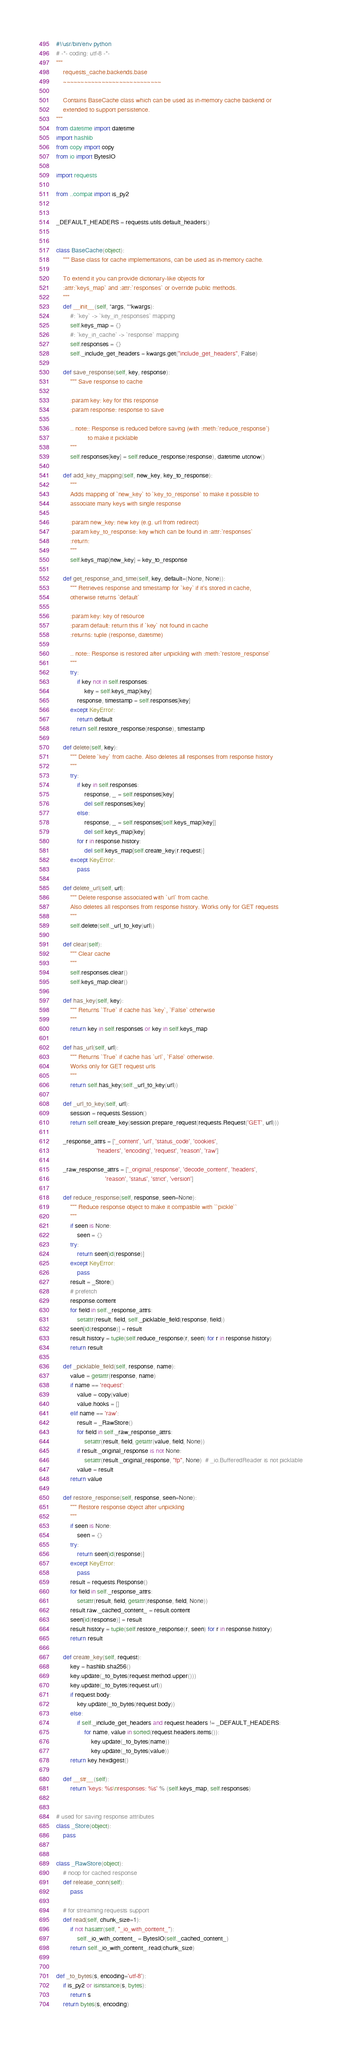<code> <loc_0><loc_0><loc_500><loc_500><_Python_>#!/usr/bin/env python
# -*- coding: utf-8 -*-
"""
    requests_cache.backends.base
    ~~~~~~~~~~~~~~~~~~~~~~~~~~~~

    Contains BaseCache class which can be used as in-memory cache backend or
    extended to support persistence.
"""
from datetime import datetime
import hashlib
from copy import copy
from io import BytesIO

import requests

from ..compat import is_py2


_DEFAULT_HEADERS = requests.utils.default_headers()


class BaseCache(object):
    """ Base class for cache implementations, can be used as in-memory cache.

    To extend it you can provide dictionary-like objects for
    :attr:`keys_map` and :attr:`responses` or override public methods.
    """
    def __init__(self, *args, **kwargs):
        #: `key` -> `key_in_responses` mapping
        self.keys_map = {}
        #: `key_in_cache` -> `response` mapping
        self.responses = {}
        self._include_get_headers = kwargs.get("include_get_headers", False)

    def save_response(self, key, response):
        """ Save response to cache

        :param key: key for this response
        :param response: response to save

        .. note:: Response is reduced before saving (with :meth:`reduce_response`)
                  to make it picklable
        """
        self.responses[key] = self.reduce_response(response), datetime.utcnow()

    def add_key_mapping(self, new_key, key_to_response):
        """
        Adds mapping of `new_key` to `key_to_response` to make it possible to
        associate many keys with single response

        :param new_key: new key (e.g. url from redirect)
        :param key_to_response: key which can be found in :attr:`responses`
        :return:
        """
        self.keys_map[new_key] = key_to_response

    def get_response_and_time(self, key, default=(None, None)):
        """ Retrieves response and timestamp for `key` if it's stored in cache,
        otherwise returns `default`

        :param key: key of resource
        :param default: return this if `key` not found in cache
        :returns: tuple (response, datetime)

        .. note:: Response is restored after unpickling with :meth:`restore_response`
        """
        try:
            if key not in self.responses:
                key = self.keys_map[key]
            response, timestamp = self.responses[key]
        except KeyError:
            return default
        return self.restore_response(response), timestamp

    def delete(self, key):
        """ Delete `key` from cache. Also deletes all responses from response history
        """
        try:
            if key in self.responses:
                response, _ = self.responses[key]
                del self.responses[key]
            else:
                response, _ = self.responses[self.keys_map[key]]
                del self.keys_map[key]
            for r in response.history:
                del self.keys_map[self.create_key(r.request)]
        except KeyError:
            pass

    def delete_url(self, url):
        """ Delete response associated with `url` from cache.
        Also deletes all responses from response history. Works only for GET requests
        """
        self.delete(self._url_to_key(url))

    def clear(self):
        """ Clear cache
        """
        self.responses.clear()
        self.keys_map.clear()

    def has_key(self, key):
        """ Returns `True` if cache has `key`, `False` otherwise
        """
        return key in self.responses or key in self.keys_map

    def has_url(self, url):
        """ Returns `True` if cache has `url`, `False` otherwise.
        Works only for GET request urls
        """
        return self.has_key(self._url_to_key(url))

    def _url_to_key(self, url):
        session = requests.Session()
        return self.create_key(session.prepare_request(requests.Request('GET', url)))

    _response_attrs = ['_content', 'url', 'status_code', 'cookies',
                       'headers', 'encoding', 'request', 'reason', 'raw']

    _raw_response_attrs = ['_original_response', 'decode_content', 'headers',
                            'reason', 'status', 'strict', 'version']

    def reduce_response(self, response, seen=None):
        """ Reduce response object to make it compatible with ``pickle``
        """
        if seen is None:
            seen = {}
        try:
            return seen[id(response)]
        except KeyError:
            pass
        result = _Store()
        # prefetch
        response.content
        for field in self._response_attrs:
            setattr(result, field, self._picklable_field(response, field))
        seen[id(response)] = result
        result.history = tuple(self.reduce_response(r, seen) for r in response.history)
        return result

    def _picklable_field(self, response, name):
        value = getattr(response, name)
        if name == 'request':
            value = copy(value)
            value.hooks = []
        elif name == 'raw':
            result = _RawStore()
            for field in self._raw_response_attrs:
                setattr(result, field, getattr(value, field, None))
            if result._original_response is not None:
                setattr(result._original_response, "fp", None)  # _io.BufferedReader is not picklable
            value = result
        return value

    def restore_response(self, response, seen=None):
        """ Restore response object after unpickling
        """
        if seen is None:
            seen = {}
        try:
            return seen[id(response)]
        except KeyError:
            pass
        result = requests.Response()
        for field in self._response_attrs:
            setattr(result, field, getattr(response, field, None))
        result.raw._cached_content_ = result.content
        seen[id(response)] = result
        result.history = tuple(self.restore_response(r, seen) for r in response.history)
        return result

    def create_key(self, request):
        key = hashlib.sha256()
        key.update(_to_bytes(request.method.upper()))
        key.update(_to_bytes(request.url))
        if request.body:
            key.update(_to_bytes(request.body))
        else:
            if self._include_get_headers and request.headers != _DEFAULT_HEADERS:
                for name, value in sorted(request.headers.items()):
                    key.update(_to_bytes(name))
                    key.update(_to_bytes(value))
        return key.hexdigest()

    def __str__(self):
        return 'keys: %s\nresponses: %s' % (self.keys_map, self.responses)


# used for saving response attributes
class _Store(object):
    pass


class _RawStore(object):
    # noop for cached response
    def release_conn(self):
        pass

    # for streaming requests support
    def read(self, chunk_size=1):
        if not hasattr(self, "_io_with_content_"):
            self._io_with_content_ = BytesIO(self._cached_content_)
        return self._io_with_content_.read(chunk_size)


def _to_bytes(s, encoding='utf-8'):
    if is_py2 or isinstance(s, bytes):
        return s
    return bytes(s, encoding)
</code> 